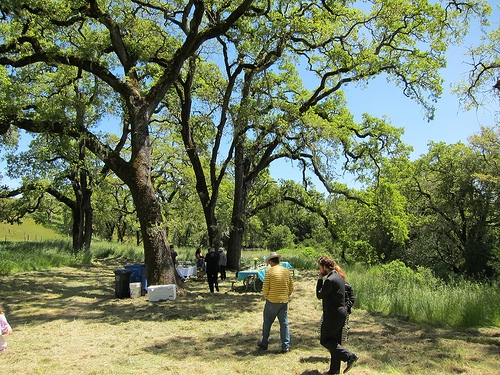<image>
Is the man to the left of the man? No. The man is not to the left of the man. From this viewpoint, they have a different horizontal relationship. 